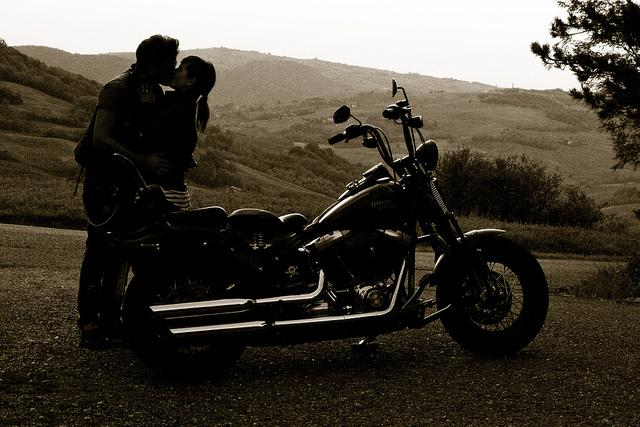What are the two feeling right now?

Choices:
A) attraction
B) disgust
C) amusement
D) hate attraction 